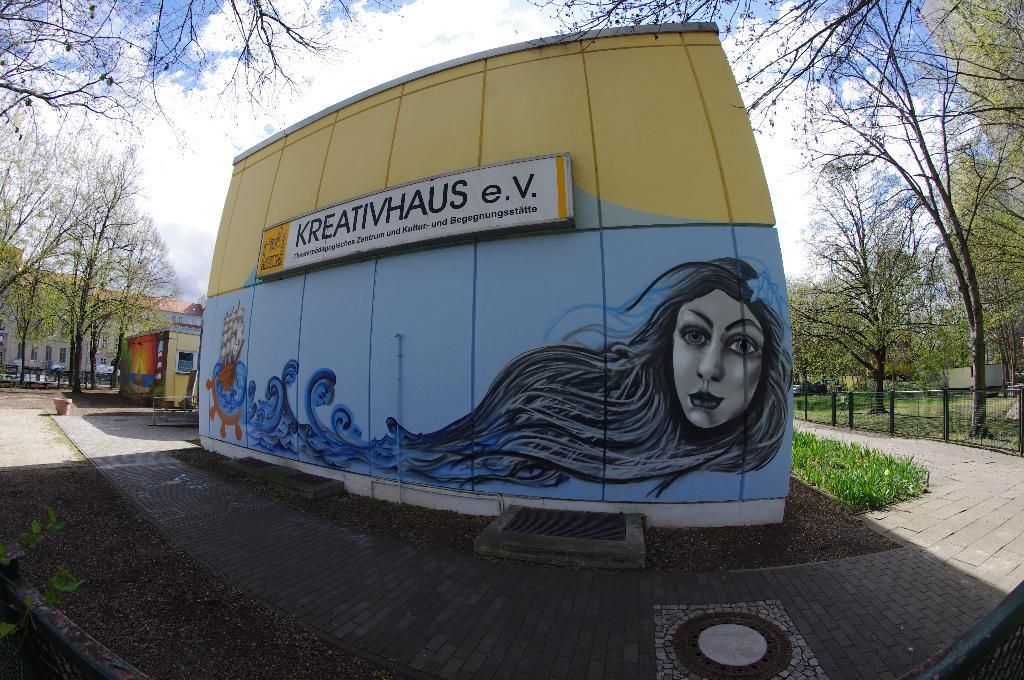What can be seen in the sky in the image? The sky with clouds is visible in the image. What type of natural elements are present in the image? There are trees and grass visible in the image. What type of man-made structures can be seen in the image? There are buildings, a shed, barrier poles, fences, and a name board present in the image. What type of artwork is visible in the image? Paintings on the wall are in the image. What is the distribution of harmony among the thoughts in the image? There is no reference to thoughts or harmony in the image, as it primarily features natural and man-made elements. 